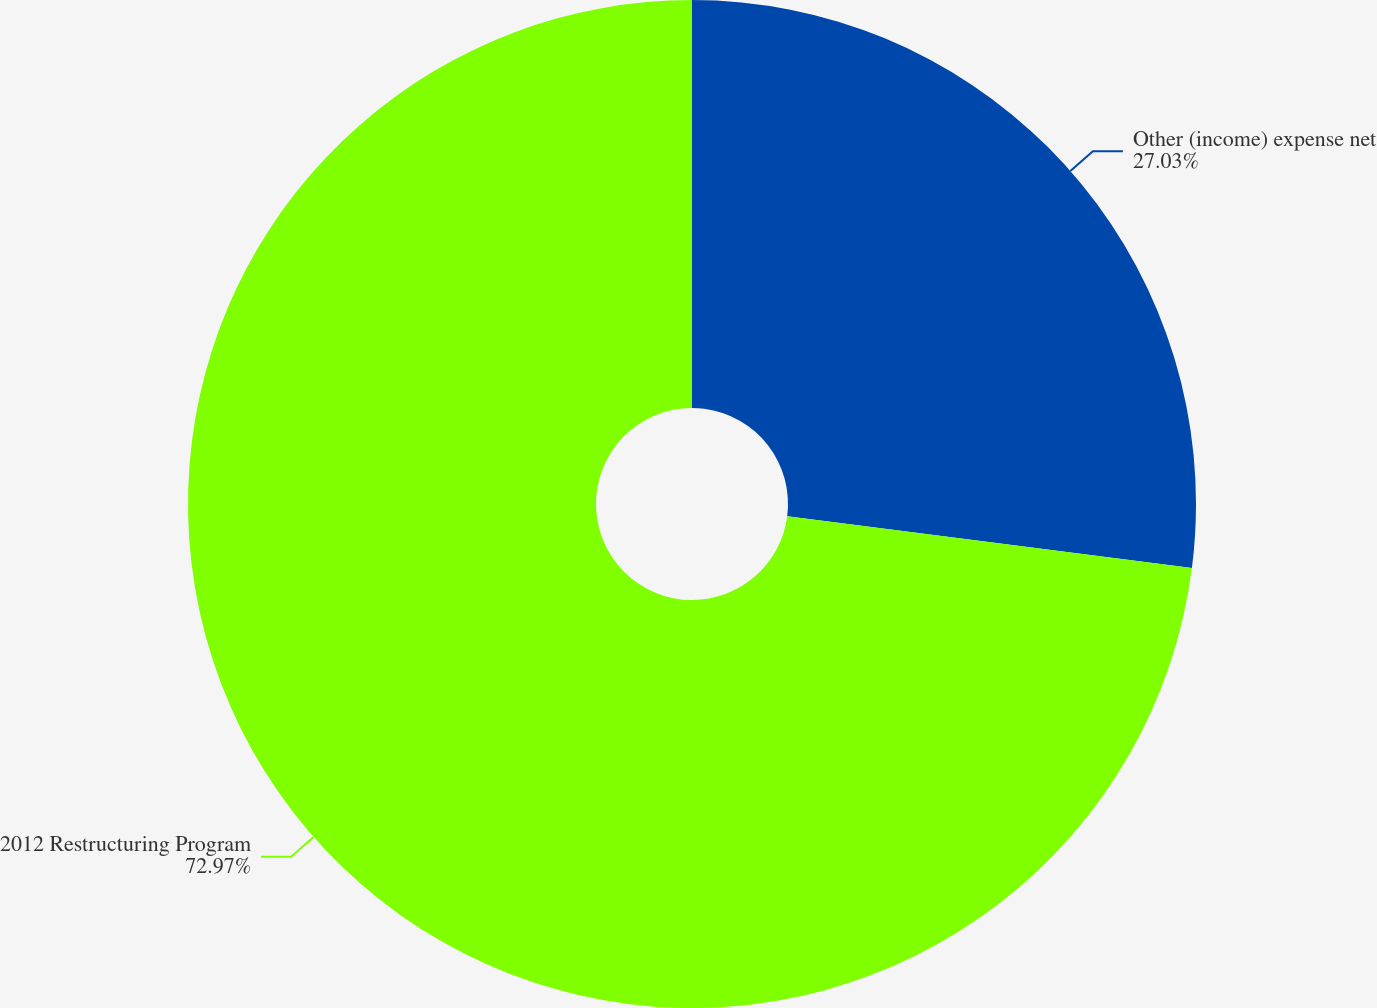Convert chart. <chart><loc_0><loc_0><loc_500><loc_500><pie_chart><fcel>Other (income) expense net<fcel>2012 Restructuring Program<nl><fcel>27.03%<fcel>72.97%<nl></chart> 